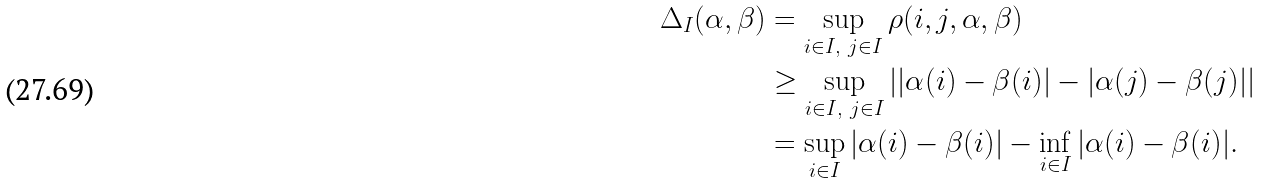<formula> <loc_0><loc_0><loc_500><loc_500>\Delta _ { I } ( \alpha , \beta ) & = \sup _ { i \in I , \ j \in I } \rho ( i , j , \alpha , \beta ) \\ & \geq \sup _ { i \in I , \ j \in I } | | \alpha ( i ) - \beta ( i ) | - | \alpha ( j ) - \beta ( j ) | | \\ & = \sup _ { i \in I } | \alpha ( i ) - \beta ( i ) | - \inf _ { i \in I } | \alpha ( i ) - \beta ( i ) | .</formula> 